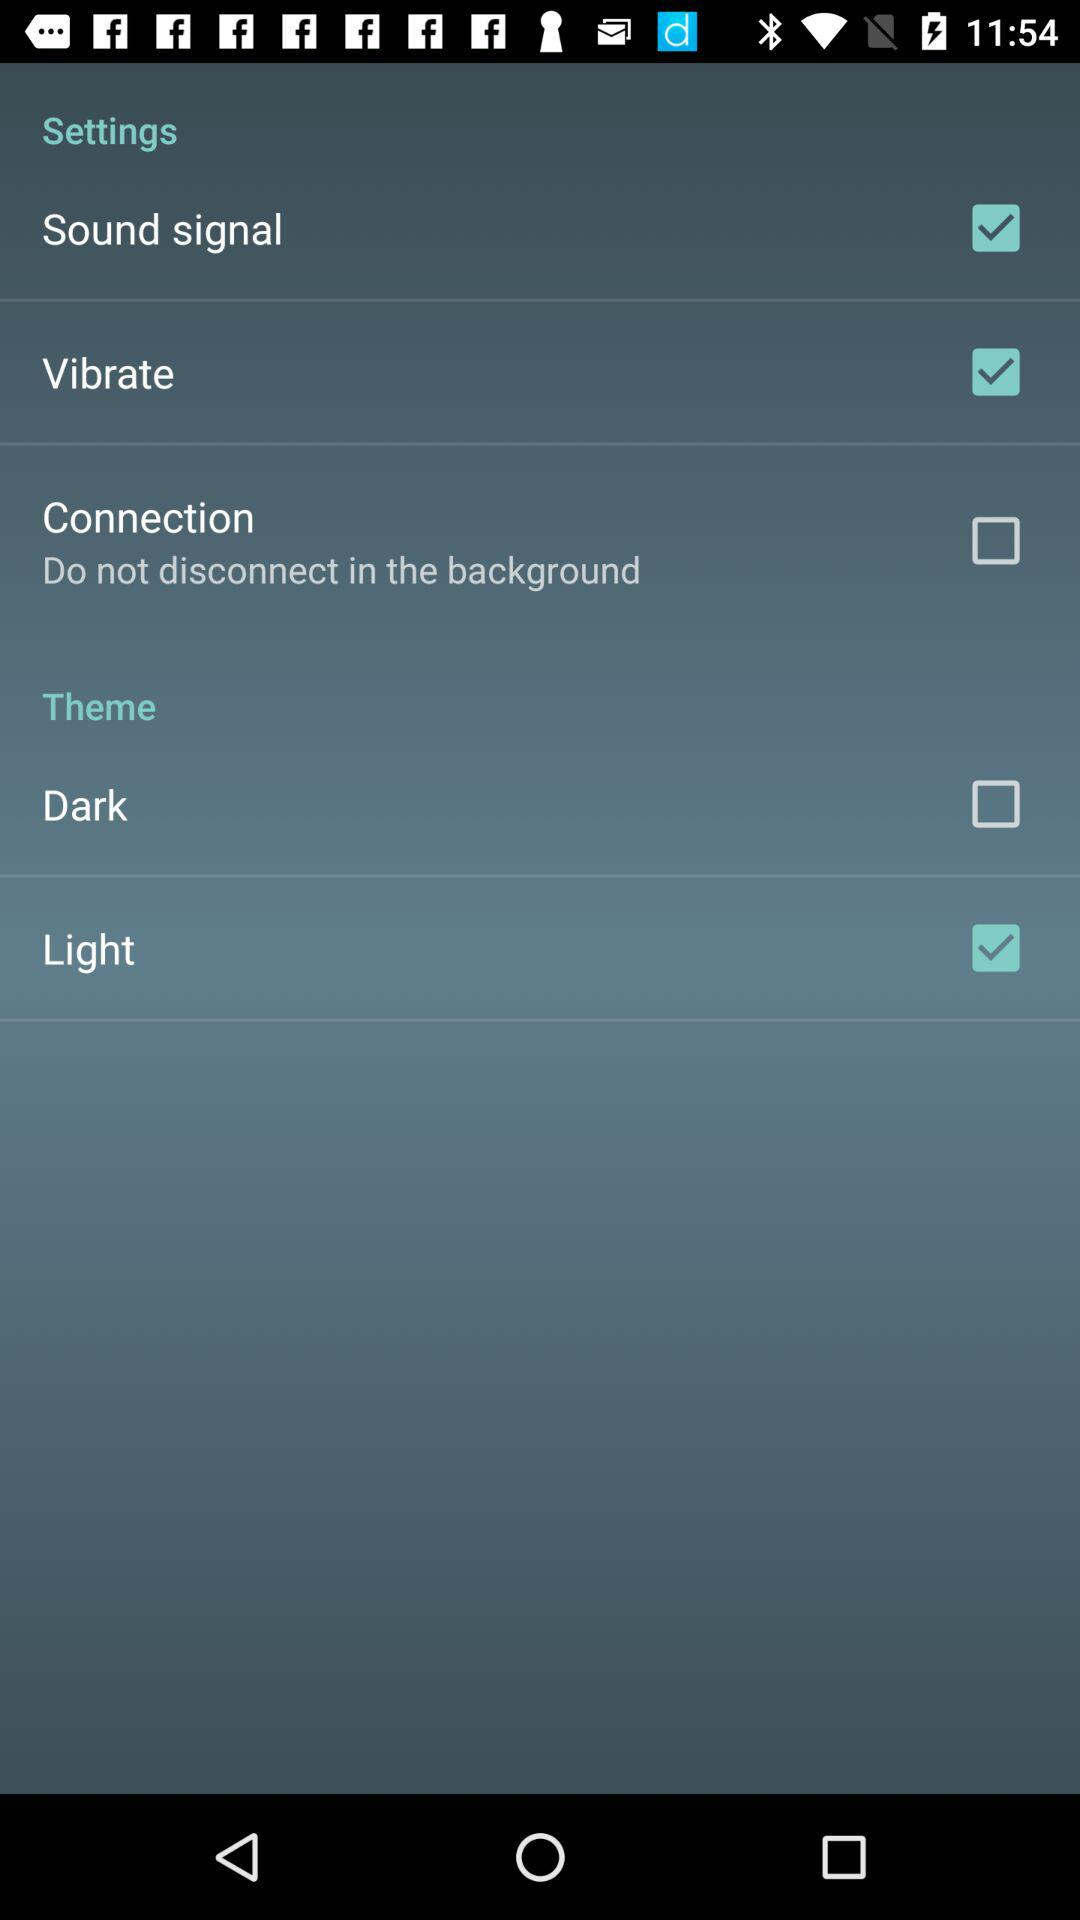What is the status of the "Connection" setting? The status is "off". 